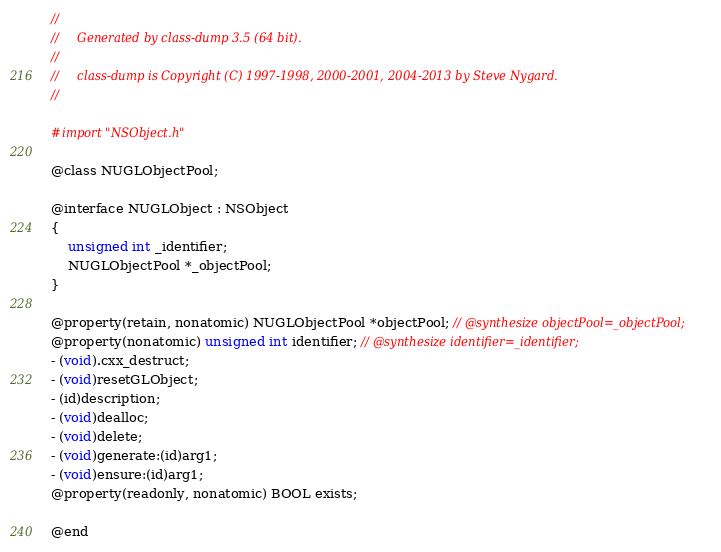<code> <loc_0><loc_0><loc_500><loc_500><_C_>//
//     Generated by class-dump 3.5 (64 bit).
//
//     class-dump is Copyright (C) 1997-1998, 2000-2001, 2004-2013 by Steve Nygard.
//

#import "NSObject.h"

@class NUGLObjectPool;

@interface NUGLObject : NSObject
{
    unsigned int _identifier;
    NUGLObjectPool *_objectPool;
}

@property(retain, nonatomic) NUGLObjectPool *objectPool; // @synthesize objectPool=_objectPool;
@property(nonatomic) unsigned int identifier; // @synthesize identifier=_identifier;
- (void).cxx_destruct;
- (void)resetGLObject;
- (id)description;
- (void)dealloc;
- (void)delete;
- (void)generate:(id)arg1;
- (void)ensure:(id)arg1;
@property(readonly, nonatomic) BOOL exists;

@end

</code> 